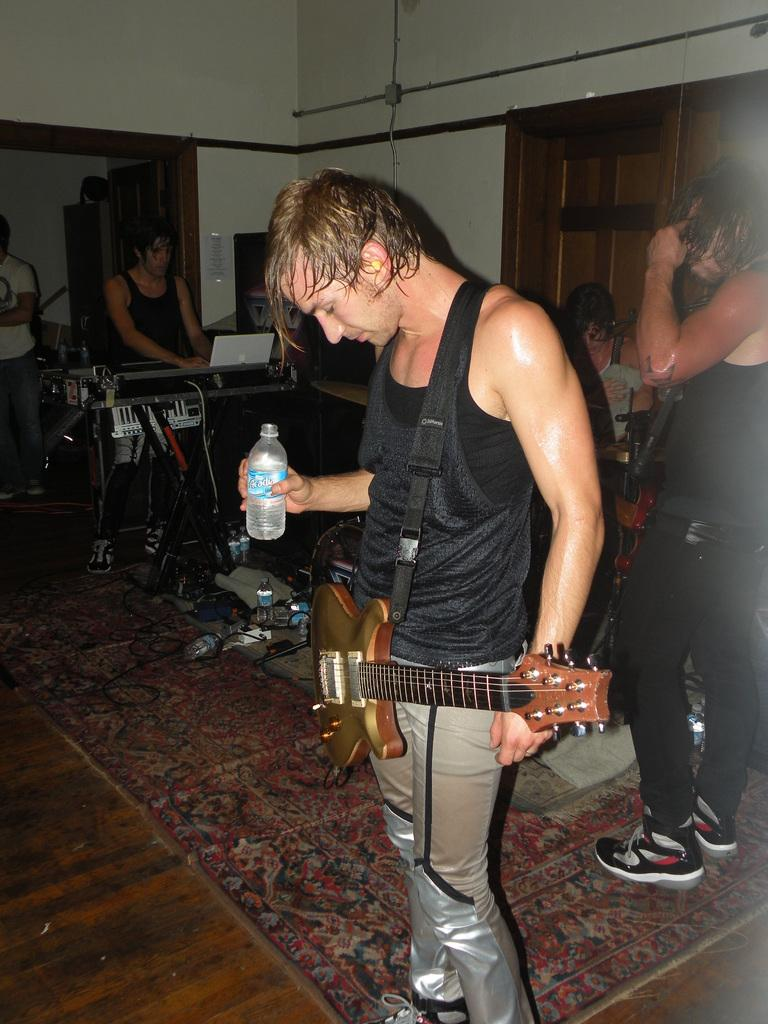What is the man in the image holding? The man is holding a guitar and a water bottle in the image. What is the other man in the image doing? The other man is playing musical instruments in the image. What can be seen in the background of the image? There is a wall in the image. What type of circle can be seen in the image? There is no circle present in the image. What statement is being made by the man holding the guitar? The image does not provide any information about a statement being made by the man holding the guitar. 